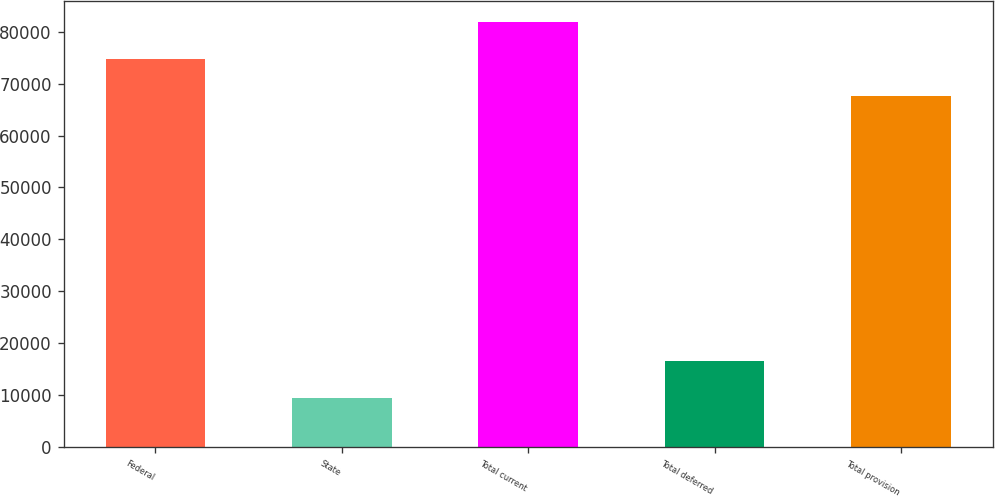Convert chart to OTSL. <chart><loc_0><loc_0><loc_500><loc_500><bar_chart><fcel>Federal<fcel>State<fcel>Total current<fcel>Total deferred<fcel>Total provision<nl><fcel>74687<fcel>9480<fcel>81851<fcel>16644<fcel>67523<nl></chart> 